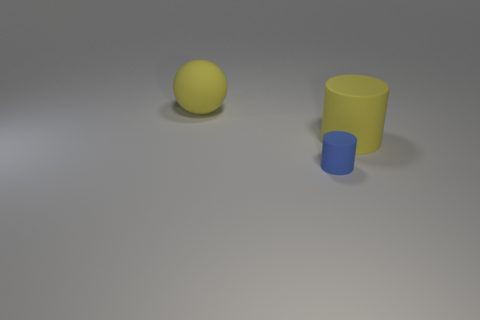What is the purpose of these objects, or what might they represent? Without additional context, these objects could be simple geometric shapes used for a variety of purposes, from visual aids in a presentation to elements in a 3D modeling software tutorial. Their simplicity suggests they could be used to illustrate basic concepts like shape, color, and size comparison. 